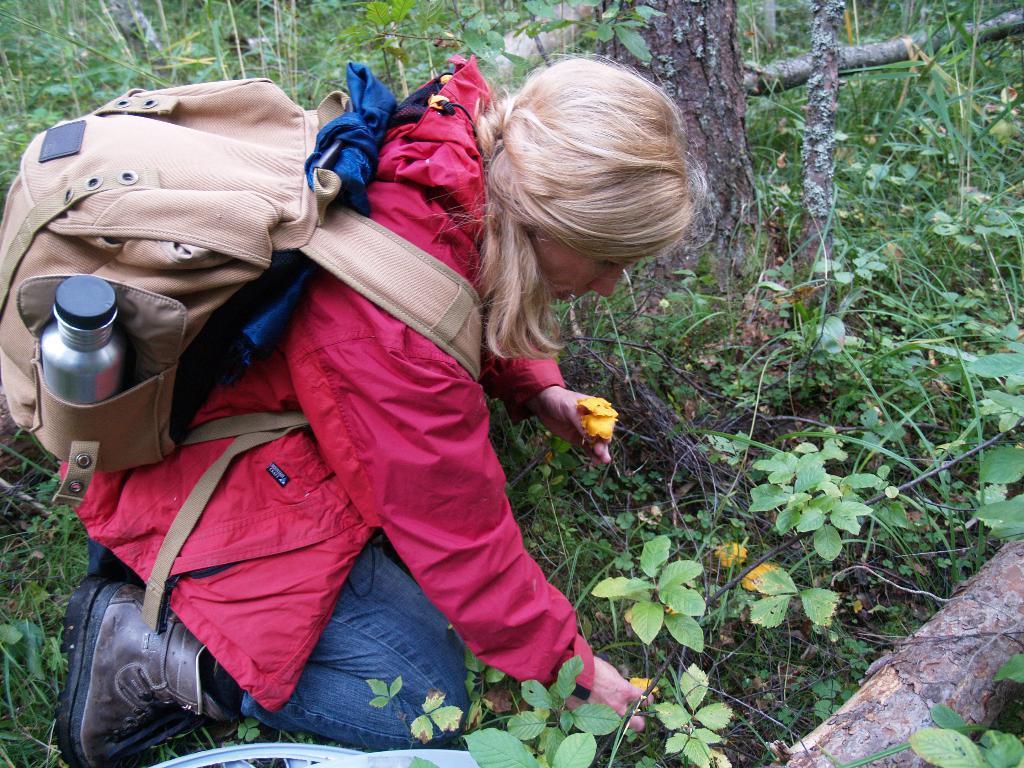Please provide a concise description of this image. In this picture, we see a woman is wearing the red jacket and a brown backpack. She is plucking the yellow flowers. At the bottom, we see the plants or trees which have flowers and these flowers are in yellow color. In the right bottom, we see a wooden stick. There are trees in the background. 